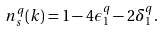<formula> <loc_0><loc_0><loc_500><loc_500>n ^ { q } _ { s } ( k ) = 1 - 4 \epsilon ^ { q } _ { 1 } - 2 \delta ^ { q } _ { 1 } .</formula> 